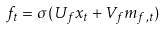<formula> <loc_0><loc_0><loc_500><loc_500>f _ { t } = \sigma ( U _ { f } x _ { t } + V _ { f } m _ { f , t } )</formula> 